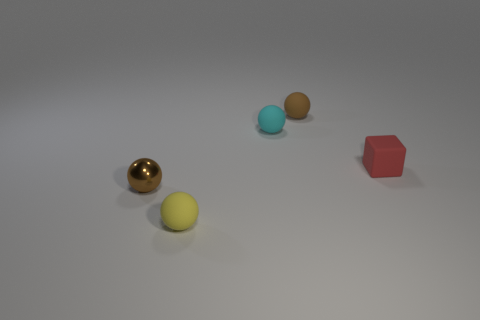Do the brown shiny ball and the brown thing behind the cube have the same size?
Your answer should be very brief. Yes. Is there any other thing that has the same shape as the red matte object?
Provide a short and direct response. No. There is a small metallic object that is the same shape as the brown rubber thing; what color is it?
Provide a succinct answer. Brown. Is the size of the cyan object the same as the brown matte ball?
Provide a short and direct response. Yes. What number of other objects are the same size as the yellow matte thing?
Offer a terse response. 4. How many things are tiny brown objects that are to the right of the tiny shiny object or small brown balls that are in front of the small red matte block?
Offer a very short reply. 2. The cyan thing that is the same size as the brown rubber thing is what shape?
Your response must be concise. Sphere. There is a cube that is made of the same material as the cyan ball; what is its size?
Your answer should be compact. Small. Does the yellow object have the same shape as the tiny cyan rubber object?
Make the answer very short. Yes. What is the color of the block that is the same size as the brown shiny thing?
Offer a very short reply. Red. 